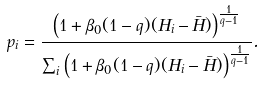<formula> <loc_0><loc_0><loc_500><loc_500>p _ { i } = \frac { \left ( 1 + \beta _ { 0 } ( 1 - q ) ( H _ { i } - \bar { H } ) \right ) ^ { \frac { 1 } { q - 1 } } } { \sum _ { i } \left ( 1 + \beta _ { 0 } ( 1 - q ) ( H _ { i } - \bar { H } ) \right ) ^ { \frac { 1 } { q - 1 } } } .</formula> 